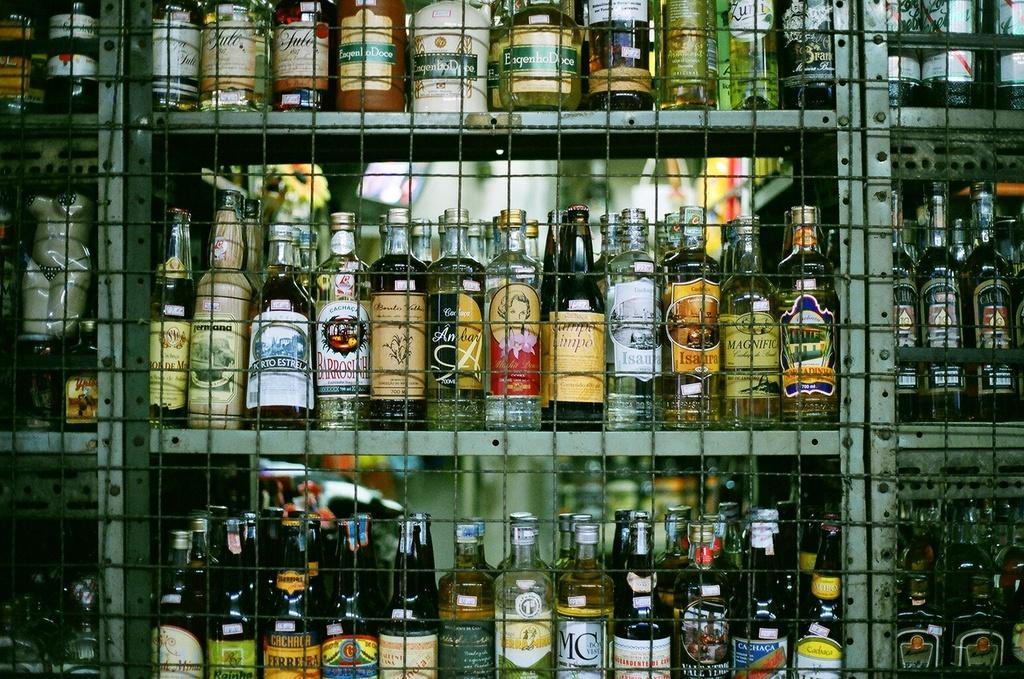What type of bottles are visible in the image? There are wine bottles in the image. Where are the wine bottles placed? The wine bottles are kept on shelves. What additional feature can be seen around the shelves? The shelves are covered by a fence. How many eyes can be seen on the sign in the image? There is no sign present in the image, so there are no eyes to count. 